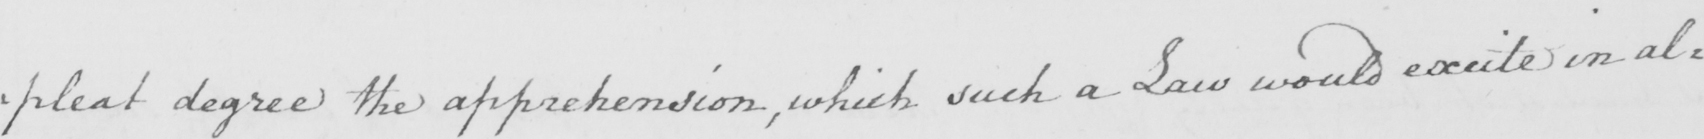Please transcribe the handwritten text in this image. : pleat degree the apprehension , which such a Law would excite in al= 